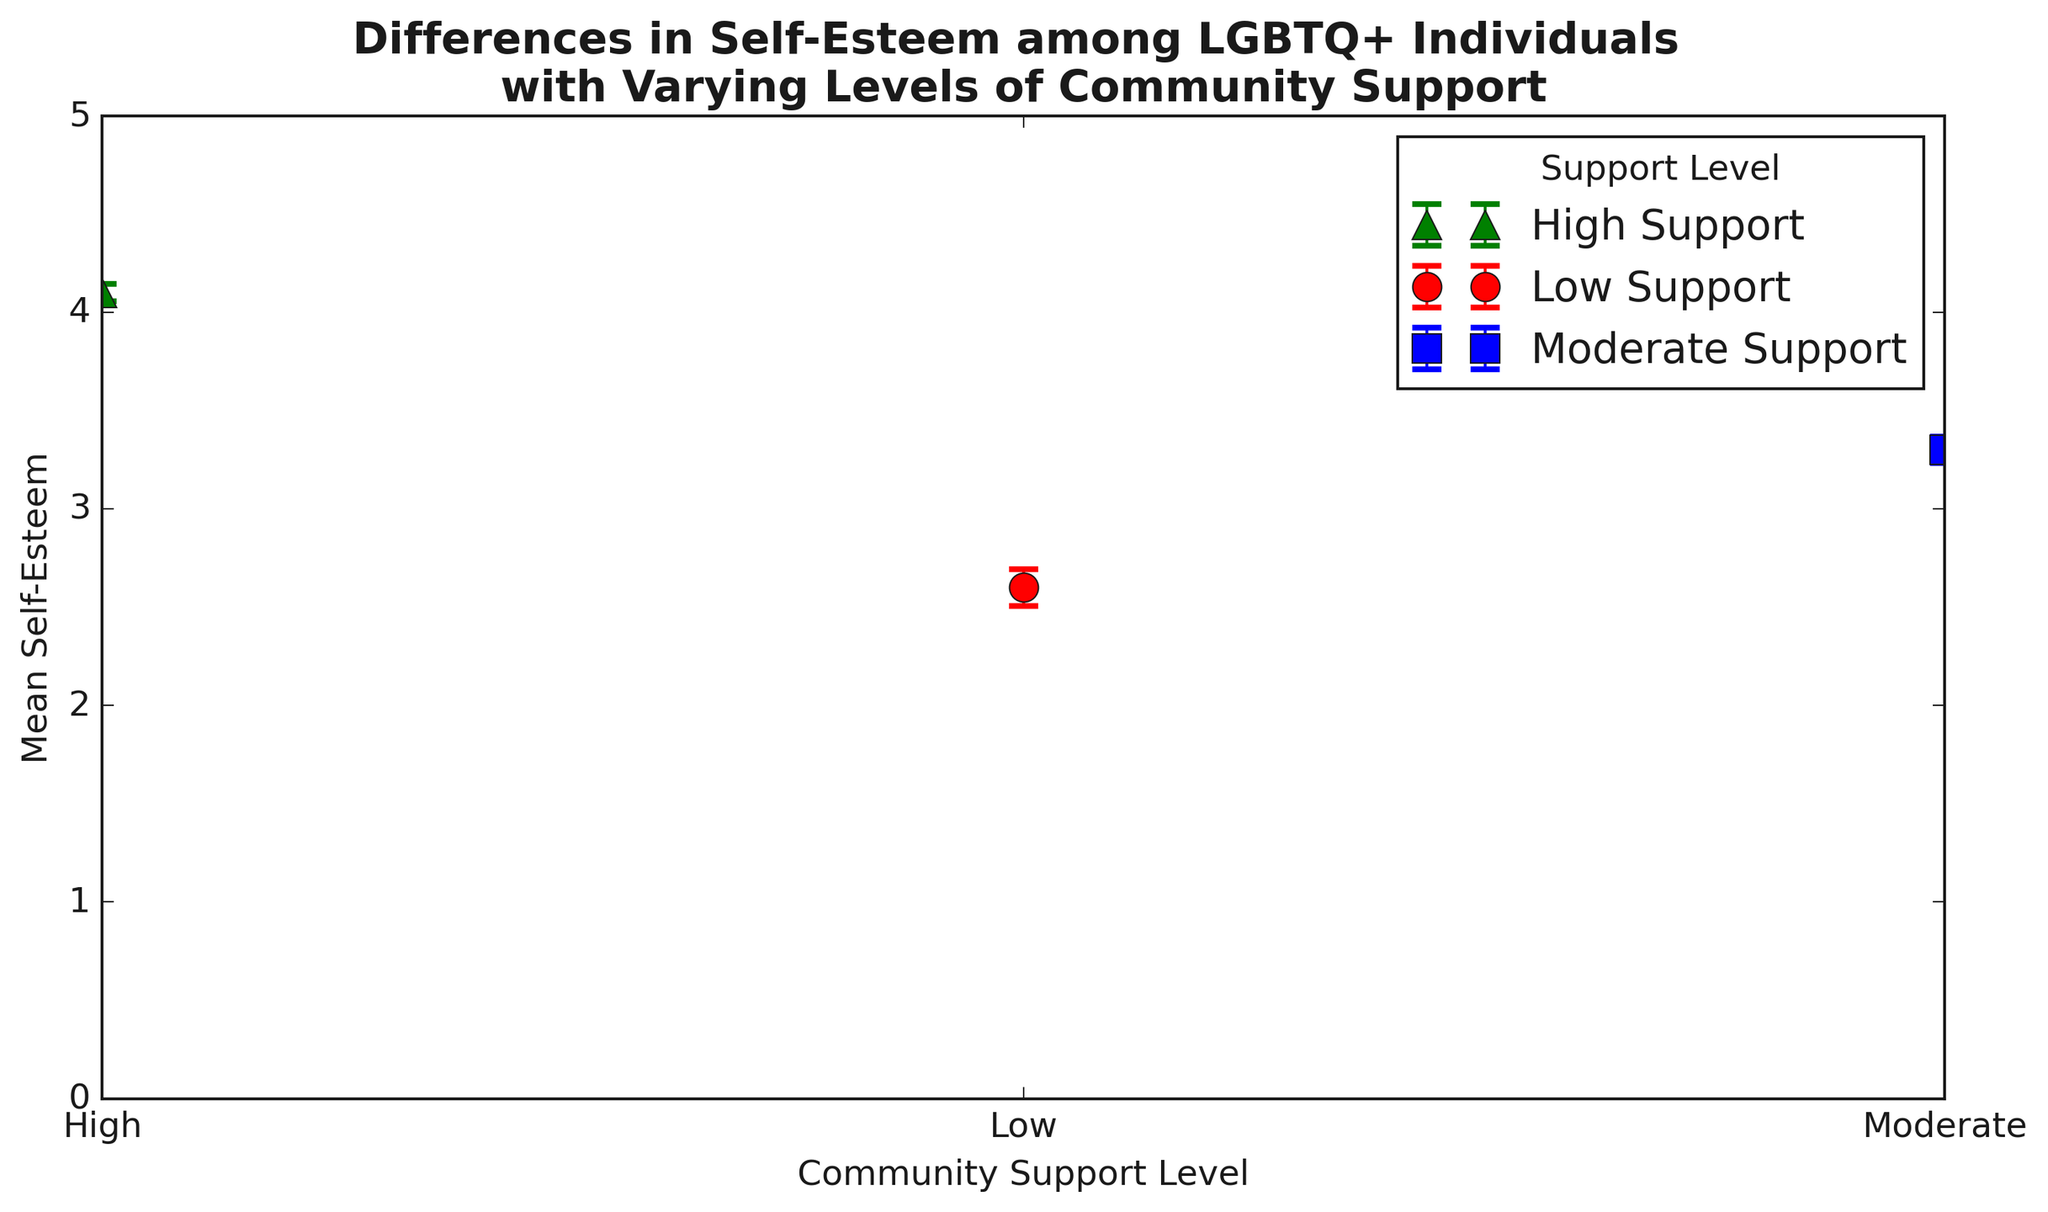What's the mean self-esteem score for individuals with moderate community support? Find the data point representing moderate community support and read the mean self-esteem value.
Answer: 3.3 How does the mean self-esteem for high community support compare to low community support? Compare the mean self-esteem values for high and low community support: 4.1 (high) and 2.6 (low). High community support has a higher mean self-esteem.
Answer: High is higher What is the difference in mean self-esteem between individuals with high and low community support? Calculate the difference between the mean self-esteem values of high (4.1) and low (2.6) community support.
Answer: 1.5 Which community support level shows the highest variability in self-esteem scores, and how can you tell? Look for the highest standard deviation values among the three levels. Low community support has a standard deviation of 0.85, which is the highest.
Answer: Low For which community support level are the error bars the longest? Identify the error bars’ lengths by checking the error values: low (≈0.16), moderate (≈0.12), and high (≈0.08). The longest error bar is for low community support.
Answer: Low What is the total sample size across all community support levels? Sum the sample sizes for low (83), moderate (127), and high (157) community support.
Answer: 367 How does the error margin for low community support compare with moderate community support? Compare the error values: 0.85/sqrt(83) ≈ 0.093 (low) vs. 0.75/sqrt(127) ≈ 0.067 (moderate). The error margin for low support is larger.
Answer: Low is larger Which group shows the highest mean self-esteem? Identify the group with the highest mean self-esteem value, which is high community support at 4.1.
Answer: High What is the average mean self-esteem for all support levels combined? Calculate the average of the mean self-esteem values: (2.6 + 3.3 + 4.1)/3.
Answer: 3.33 Why might the standard errors differ among the support groups? Standard errors are influenced by the sample size and standard deviation: larger sample sizes reduce error, and higher variability increases error. Low community support has the highest standard deviation and a relatively smaller sample size, leading to a larger standard error.
Answer: Sample size and variability 